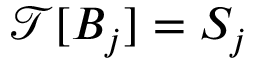<formula> <loc_0><loc_0><loc_500><loc_500>\mathcal { T } [ B _ { j } ] = S _ { j }</formula> 